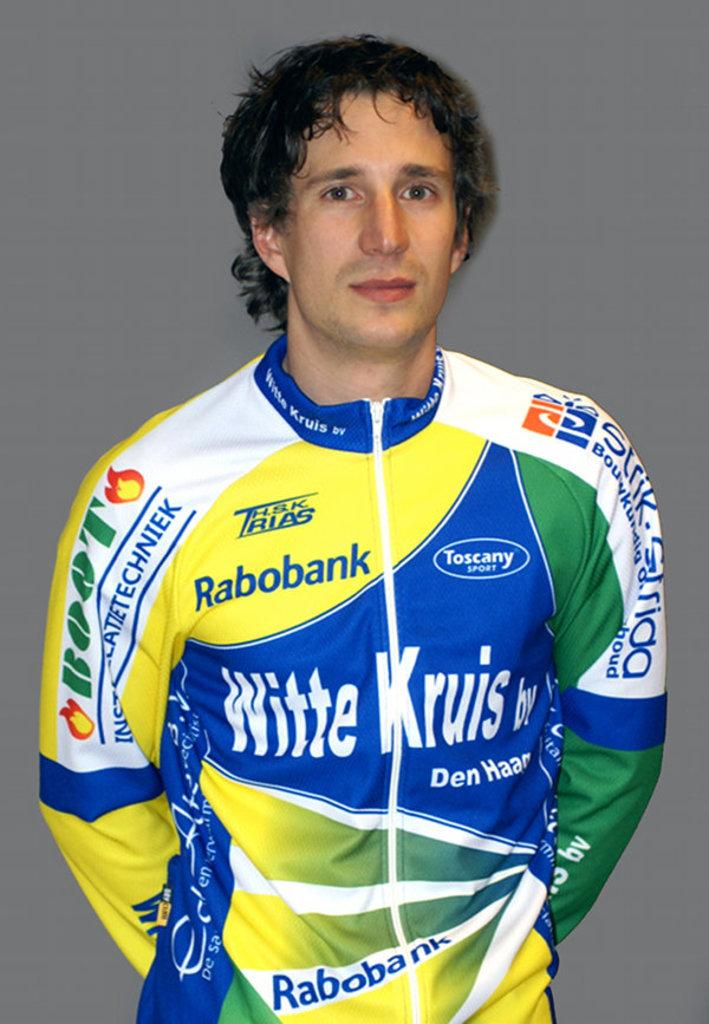<image>
Render a clear and concise summary of the photo. A man in a colorful sports top with the word Rabobank on it 